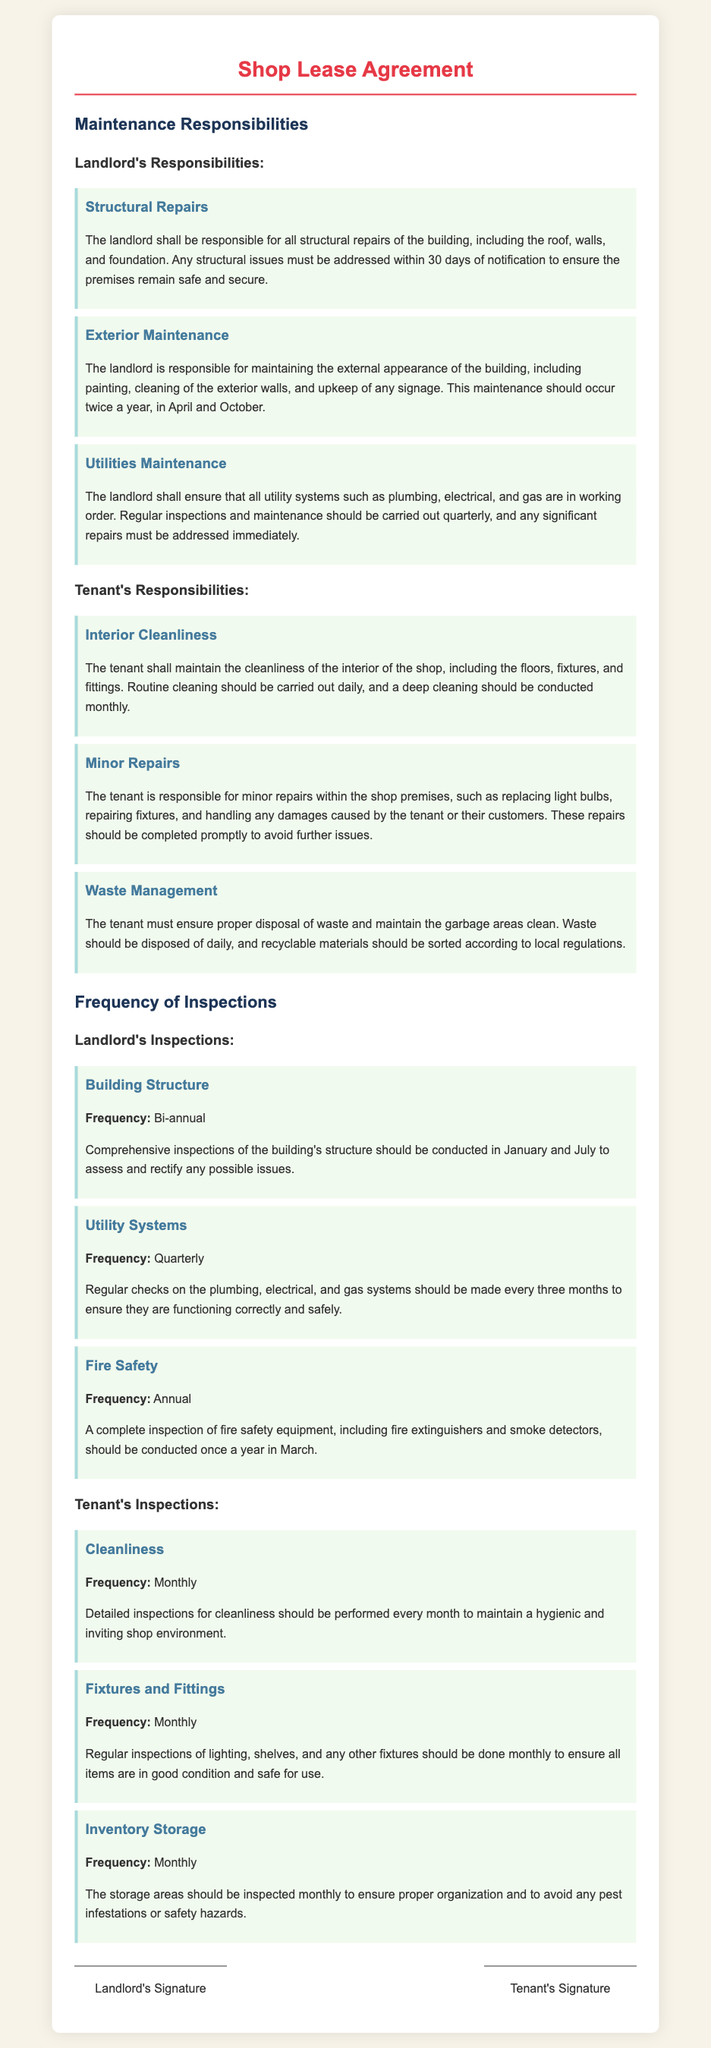What are the landlord's responsibilities for structural repairs? The landlord is responsible for all structural repairs of the building, including the roof, walls, and foundation.
Answer: Structural Repairs How often should the exterior maintenance be conducted? The landlord is responsible for maintaining the external appearance of the building twice a year, in April and October.
Answer: Twice a year What is the frequency for checking utility systems? Regular checks on plumbing, electrical, and gas systems should be made every three months.
Answer: Quarterly What responsibilities does the tenant have for interior cleanliness? The tenant shall maintain the cleanliness of the interior, including floors, fixtures, and fittings.
Answer: Cleanliness of the interior What is the frequency of inspections for fire safety equipment? A complete inspection of fire safety equipment should be conducted once a year.
Answer: Annual How often should the tenant inspect the storage areas? The storage areas should be inspected monthly to ensure proper organization.
Answer: Monthly What should the landlord do about structural issues? Any structural issues must be addressed within 30 days of notification.
Answer: Within 30 days When should the landlord conduct comprehensive inspections of the building's structure? Comprehensive inspections should be conducted in January and July.
Answer: January and July What maintenance task is the tenant responsible for regarding waste? The tenant must ensure proper disposal of waste and maintain the garbage areas clean.
Answer: Proper disposal of waste 